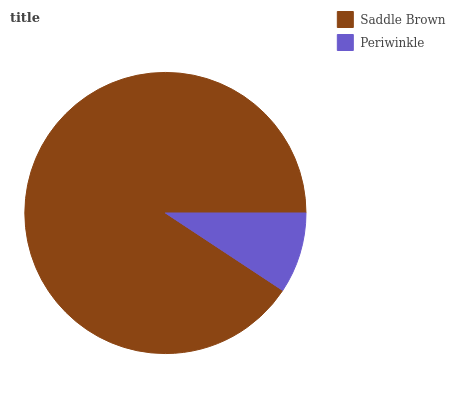Is Periwinkle the minimum?
Answer yes or no. Yes. Is Saddle Brown the maximum?
Answer yes or no. Yes. Is Periwinkle the maximum?
Answer yes or no. No. Is Saddle Brown greater than Periwinkle?
Answer yes or no. Yes. Is Periwinkle less than Saddle Brown?
Answer yes or no. Yes. Is Periwinkle greater than Saddle Brown?
Answer yes or no. No. Is Saddle Brown less than Periwinkle?
Answer yes or no. No. Is Saddle Brown the high median?
Answer yes or no. Yes. Is Periwinkle the low median?
Answer yes or no. Yes. Is Periwinkle the high median?
Answer yes or no. No. Is Saddle Brown the low median?
Answer yes or no. No. 